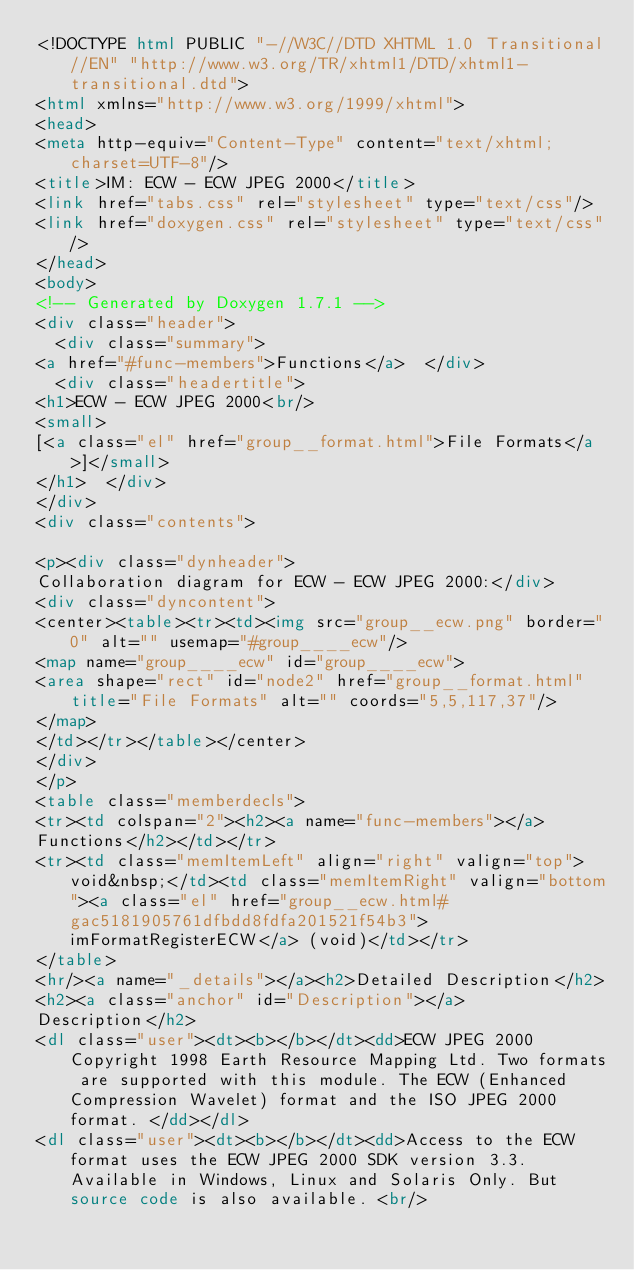Convert code to text. <code><loc_0><loc_0><loc_500><loc_500><_HTML_><!DOCTYPE html PUBLIC "-//W3C//DTD XHTML 1.0 Transitional//EN" "http://www.w3.org/TR/xhtml1/DTD/xhtml1-transitional.dtd">
<html xmlns="http://www.w3.org/1999/xhtml">
<head>
<meta http-equiv="Content-Type" content="text/xhtml;charset=UTF-8"/>
<title>IM: ECW - ECW JPEG 2000</title>
<link href="tabs.css" rel="stylesheet" type="text/css"/>
<link href="doxygen.css" rel="stylesheet" type="text/css"/>
</head>
<body>
<!-- Generated by Doxygen 1.7.1 -->
<div class="header">
  <div class="summary">
<a href="#func-members">Functions</a>  </div>
  <div class="headertitle">
<h1>ECW - ECW JPEG 2000<br/>
<small>
[<a class="el" href="group__format.html">File Formats</a>]</small>
</h1>  </div>
</div>
<div class="contents">

<p><div class="dynheader">
Collaboration diagram for ECW - ECW JPEG 2000:</div>
<div class="dyncontent">
<center><table><tr><td><img src="group__ecw.png" border="0" alt="" usemap="#group____ecw"/>
<map name="group____ecw" id="group____ecw">
<area shape="rect" id="node2" href="group__format.html" title="File Formats" alt="" coords="5,5,117,37"/></map>
</td></tr></table></center>
</div>
</p>
<table class="memberdecls">
<tr><td colspan="2"><h2><a name="func-members"></a>
Functions</h2></td></tr>
<tr><td class="memItemLeft" align="right" valign="top">void&nbsp;</td><td class="memItemRight" valign="bottom"><a class="el" href="group__ecw.html#gac5181905761dfbdd8fdfa201521f54b3">imFormatRegisterECW</a> (void)</td></tr>
</table>
<hr/><a name="_details"></a><h2>Detailed Description</h2>
<h2><a class="anchor" id="Description"></a>
Description</h2>
<dl class="user"><dt><b></b></dt><dd>ECW JPEG 2000 Copyright 1998 Earth Resource Mapping Ltd. Two formats are supported with this module. The ECW (Enhanced Compression Wavelet) format and the ISO JPEG 2000 format. </dd></dl>
<dl class="user"><dt><b></b></dt><dd>Access to the ECW format uses the ECW JPEG 2000 SDK version 3.3. Available in Windows, Linux and Solaris Only. But source code is also available. <br/></code> 